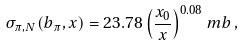Convert formula to latex. <formula><loc_0><loc_0><loc_500><loc_500>\sigma _ { \pi , N } ( b _ { \pi } , x ) = 2 3 . 7 8 \left ( \frac { x _ { 0 } } { x } \right ) ^ { 0 . 0 8 } m b \, ,</formula> 